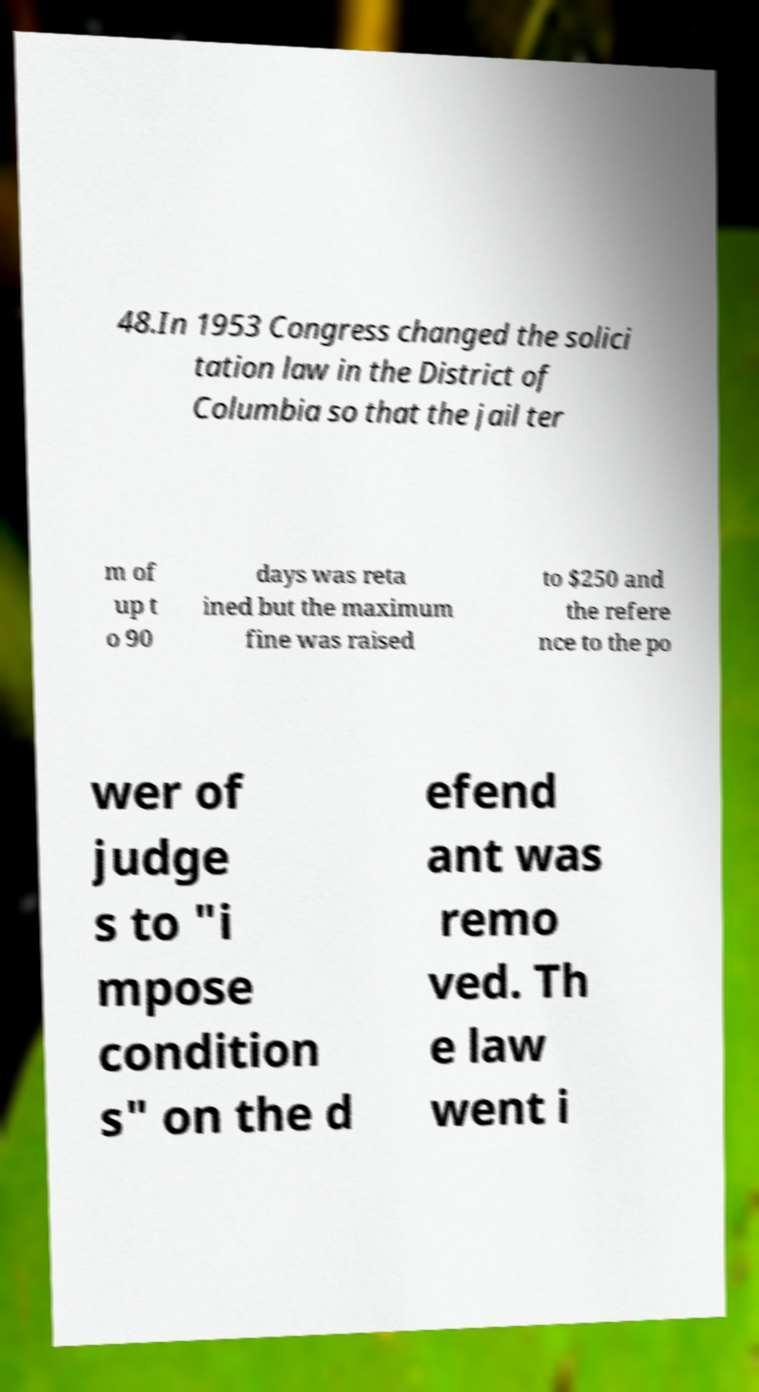Please identify and transcribe the text found in this image. 48.In 1953 Congress changed the solici tation law in the District of Columbia so that the jail ter m of up t o 90 days was reta ined but the maximum fine was raised to $250 and the refere nce to the po wer of judge s to "i mpose condition s" on the d efend ant was remo ved. Th e law went i 